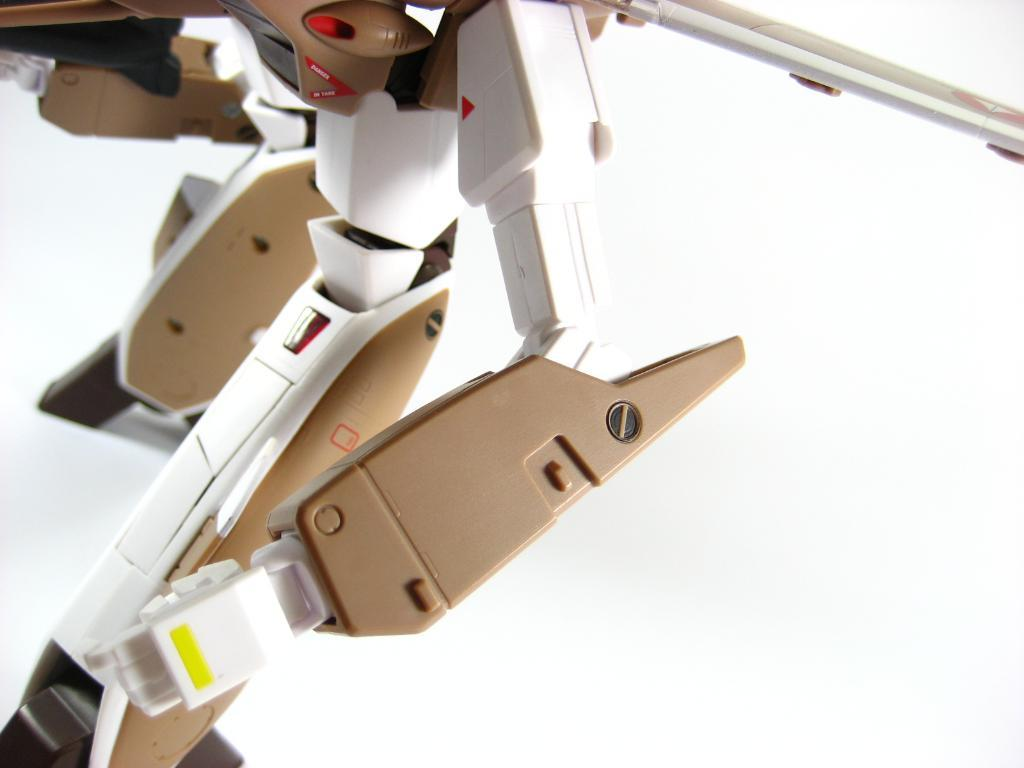What is on the floor in the image? There are objects on the floor in the image. What type of image is depicted in the photo frame? The provided facts do not specify the contents of the photo frame, so we cannot answer this question definitively. How many parts of the ocean can be seen in the image? There is no ocean present in the image, so we cannot answer this question. 